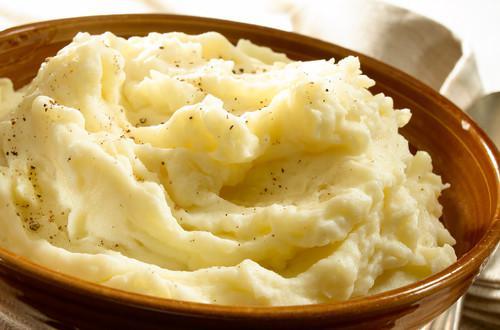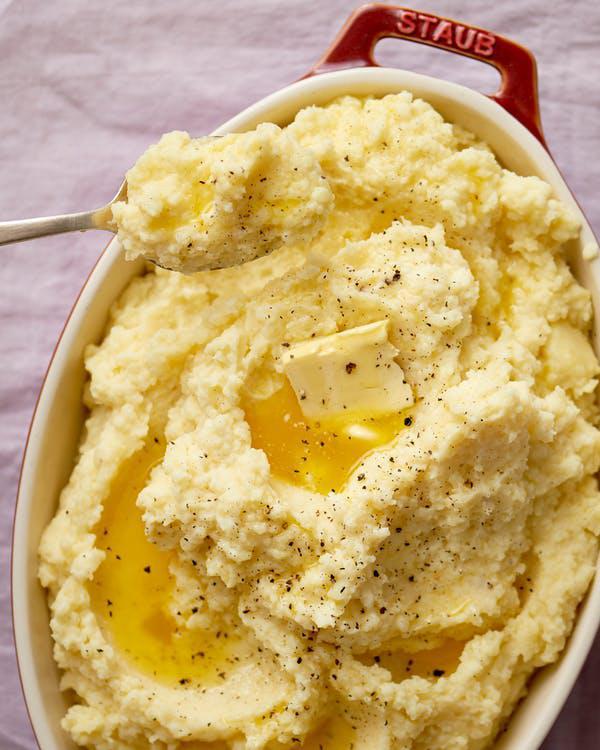The first image is the image on the left, the second image is the image on the right. Examine the images to the left and right. Is the description "One bowl of mashed potatoes has visible pools of melted butter, and the other does not." accurate? Answer yes or no. Yes. 